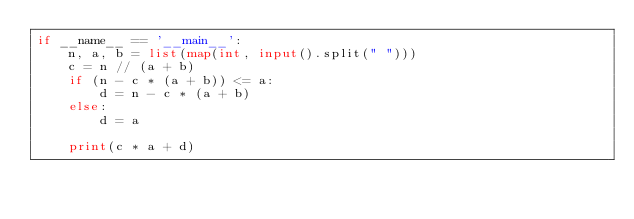Convert code to text. <code><loc_0><loc_0><loc_500><loc_500><_Python_>if __name__ == '__main__':
    n, a, b = list(map(int, input().split(" ")))
    c = n // (a + b)
    if (n - c * (a + b)) <= a:
        d = n - c * (a + b)
    else:
        d = a

    print(c * a + d)</code> 